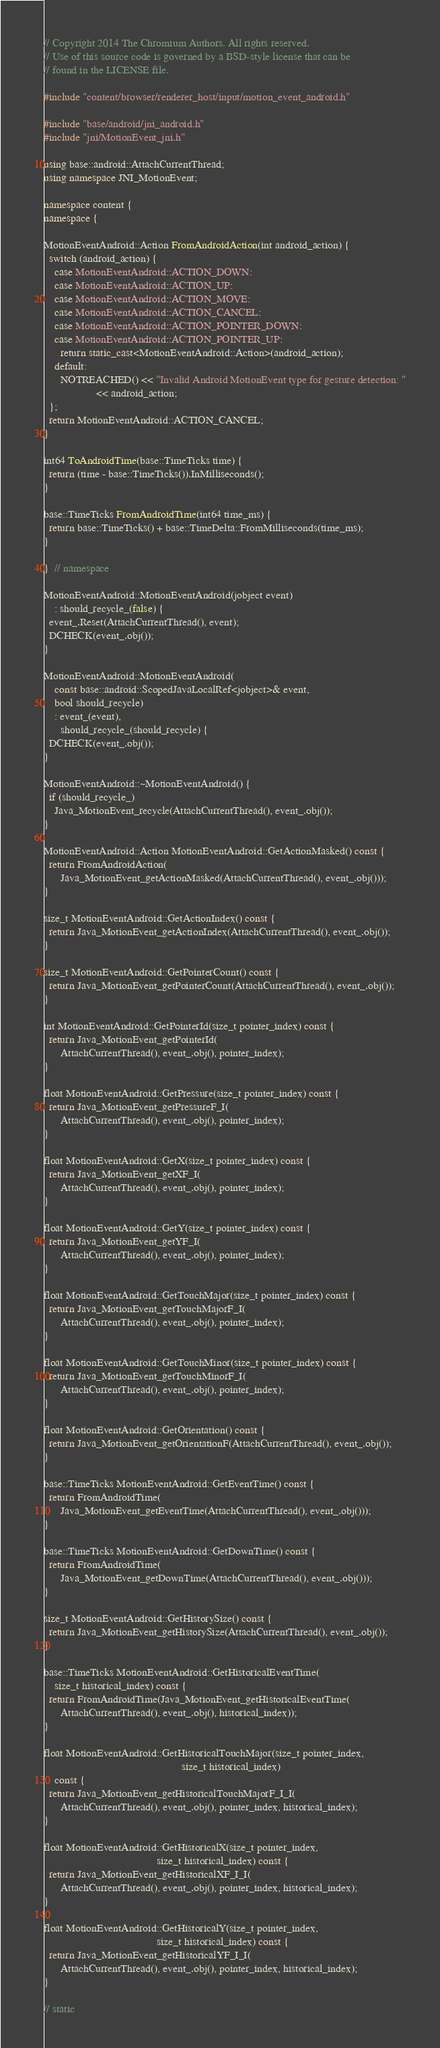Convert code to text. <code><loc_0><loc_0><loc_500><loc_500><_C++_>// Copyright 2014 The Chromium Authors. All rights reserved.
// Use of this source code is governed by a BSD-style license that can be
// found in the LICENSE file.

#include "content/browser/renderer_host/input/motion_event_android.h"

#include "base/android/jni_android.h"
#include "jni/MotionEvent_jni.h"

using base::android::AttachCurrentThread;
using namespace JNI_MotionEvent;

namespace content {
namespace {

MotionEventAndroid::Action FromAndroidAction(int android_action) {
  switch (android_action) {
    case MotionEventAndroid::ACTION_DOWN:
    case MotionEventAndroid::ACTION_UP:
    case MotionEventAndroid::ACTION_MOVE:
    case MotionEventAndroid::ACTION_CANCEL:
    case MotionEventAndroid::ACTION_POINTER_DOWN:
    case MotionEventAndroid::ACTION_POINTER_UP:
      return static_cast<MotionEventAndroid::Action>(android_action);
    default:
      NOTREACHED() << "Invalid Android MotionEvent type for gesture detection: "
                   << android_action;
  };
  return MotionEventAndroid::ACTION_CANCEL;
}

int64 ToAndroidTime(base::TimeTicks time) {
  return (time - base::TimeTicks()).InMilliseconds();
}

base::TimeTicks FromAndroidTime(int64 time_ms) {
  return base::TimeTicks() + base::TimeDelta::FromMilliseconds(time_ms);
}

}  // namespace

MotionEventAndroid::MotionEventAndroid(jobject event)
    : should_recycle_(false) {
  event_.Reset(AttachCurrentThread(), event);
  DCHECK(event_.obj());
}

MotionEventAndroid::MotionEventAndroid(
    const base::android::ScopedJavaLocalRef<jobject>& event,
    bool should_recycle)
    : event_(event),
      should_recycle_(should_recycle) {
  DCHECK(event_.obj());
}

MotionEventAndroid::~MotionEventAndroid() {
  if (should_recycle_)
    Java_MotionEvent_recycle(AttachCurrentThread(), event_.obj());
}

MotionEventAndroid::Action MotionEventAndroid::GetActionMasked() const {
  return FromAndroidAction(
      Java_MotionEvent_getActionMasked(AttachCurrentThread(), event_.obj()));
}

size_t MotionEventAndroid::GetActionIndex() const {
  return Java_MotionEvent_getActionIndex(AttachCurrentThread(), event_.obj());
}

size_t MotionEventAndroid::GetPointerCount() const {
  return Java_MotionEvent_getPointerCount(AttachCurrentThread(), event_.obj());
}

int MotionEventAndroid::GetPointerId(size_t pointer_index) const {
  return Java_MotionEvent_getPointerId(
      AttachCurrentThread(), event_.obj(), pointer_index);
}

float MotionEventAndroid::GetPressure(size_t pointer_index) const {
  return Java_MotionEvent_getPressureF_I(
      AttachCurrentThread(), event_.obj(), pointer_index);
}

float MotionEventAndroid::GetX(size_t pointer_index) const {
  return Java_MotionEvent_getXF_I(
      AttachCurrentThread(), event_.obj(), pointer_index);
}

float MotionEventAndroid::GetY(size_t pointer_index) const {
  return Java_MotionEvent_getYF_I(
      AttachCurrentThread(), event_.obj(), pointer_index);
}

float MotionEventAndroid::GetTouchMajor(size_t pointer_index) const {
  return Java_MotionEvent_getTouchMajorF_I(
      AttachCurrentThread(), event_.obj(), pointer_index);
}

float MotionEventAndroid::GetTouchMinor(size_t pointer_index) const {
  return Java_MotionEvent_getTouchMinorF_I(
      AttachCurrentThread(), event_.obj(), pointer_index);
}

float MotionEventAndroid::GetOrientation() const {
  return Java_MotionEvent_getOrientationF(AttachCurrentThread(), event_.obj());
}

base::TimeTicks MotionEventAndroid::GetEventTime() const {
  return FromAndroidTime(
      Java_MotionEvent_getEventTime(AttachCurrentThread(), event_.obj()));
}

base::TimeTicks MotionEventAndroid::GetDownTime() const {
  return FromAndroidTime(
      Java_MotionEvent_getDownTime(AttachCurrentThread(), event_.obj()));
}

size_t MotionEventAndroid::GetHistorySize() const {
  return Java_MotionEvent_getHistorySize(AttachCurrentThread(), event_.obj());
}

base::TimeTicks MotionEventAndroid::GetHistoricalEventTime(
    size_t historical_index) const {
  return FromAndroidTime(Java_MotionEvent_getHistoricalEventTime(
      AttachCurrentThread(), event_.obj(), historical_index));
}

float MotionEventAndroid::GetHistoricalTouchMajor(size_t pointer_index,
                                                  size_t historical_index)
    const {
  return Java_MotionEvent_getHistoricalTouchMajorF_I_I(
      AttachCurrentThread(), event_.obj(), pointer_index, historical_index);
}

float MotionEventAndroid::GetHistoricalX(size_t pointer_index,
                                         size_t historical_index) const {
  return Java_MotionEvent_getHistoricalXF_I_I(
      AttachCurrentThread(), event_.obj(), pointer_index, historical_index);
}

float MotionEventAndroid::GetHistoricalY(size_t pointer_index,
                                         size_t historical_index) const {
  return Java_MotionEvent_getHistoricalYF_I_I(
      AttachCurrentThread(), event_.obj(), pointer_index, historical_index);
}

// static</code> 